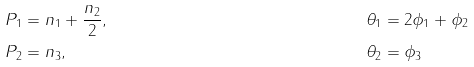<formula> <loc_0><loc_0><loc_500><loc_500>P _ { 1 } & = n _ { 1 } + \frac { n _ { 2 } } { 2 } , & \theta _ { 1 } & = 2 \phi _ { 1 } + \phi _ { 2 } \\ P _ { 2 } & = n _ { 3 } , & \theta _ { 2 } & = \phi _ { 3 }</formula> 